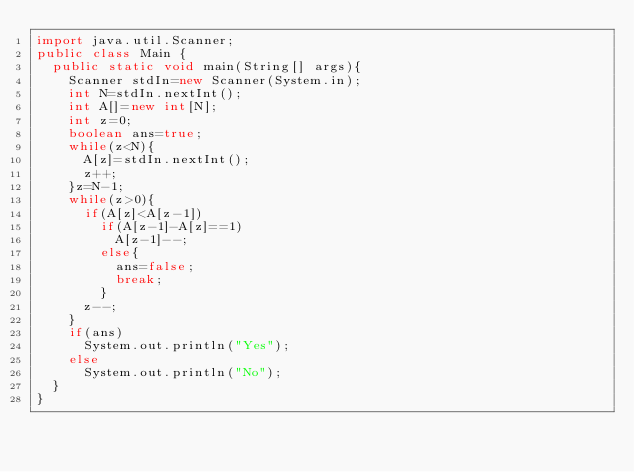<code> <loc_0><loc_0><loc_500><loc_500><_Java_>import java.util.Scanner;
public class Main {
	public static void main(String[] args){
		Scanner stdIn=new Scanner(System.in);
		int N=stdIn.nextInt();
		int A[]=new int[N];
		int z=0;
		boolean ans=true;
		while(z<N){
			A[z]=stdIn.nextInt();
			z++;
		}z=N-1;
		while(z>0){
			if(A[z]<A[z-1])
				if(A[z-1]-A[z]==1)
					A[z-1]--;
				else{
					ans=false;
					break;
				}
			z--;
		}
		if(ans)
			System.out.println("Yes");
		else
			System.out.println("No");
	}
}</code> 